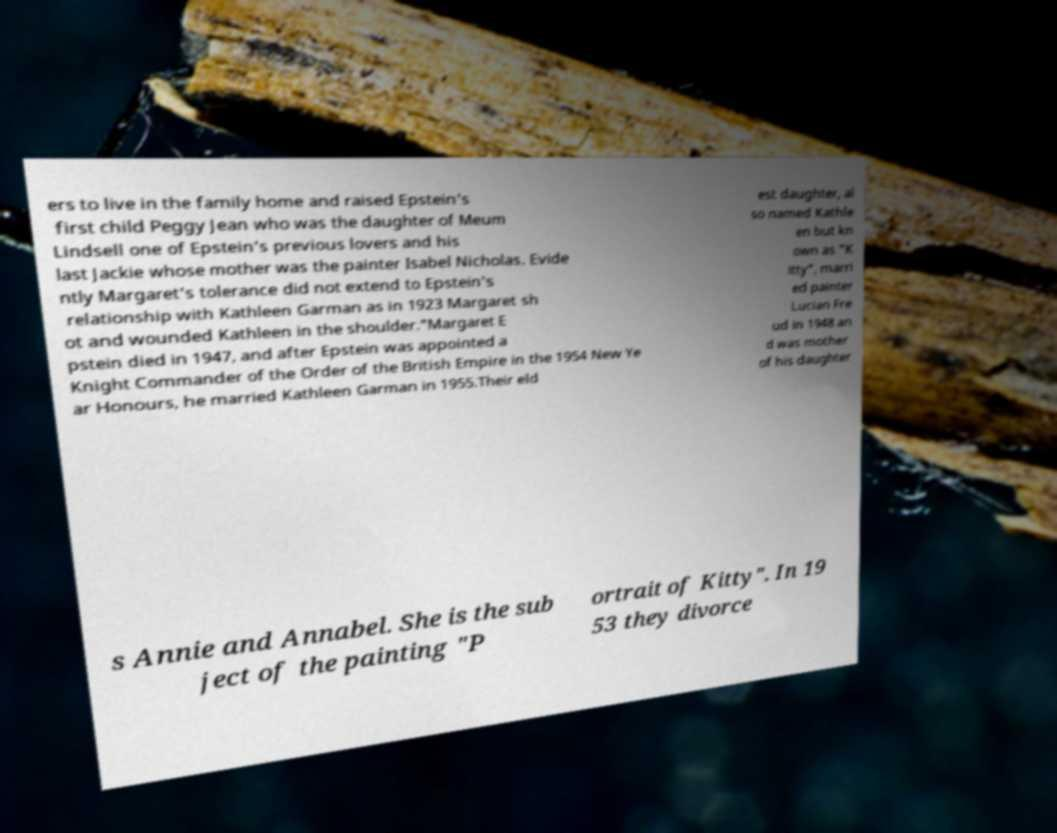Can you accurately transcribe the text from the provided image for me? ers to live in the family home and raised Epstein's first child Peggy Jean who was the daughter of Meum Lindsell one of Epstein's previous lovers and his last Jackie whose mother was the painter Isabel Nicholas. Evide ntly Margaret's tolerance did not extend to Epstein's relationship with Kathleen Garman as in 1923 Margaret sh ot and wounded Kathleen in the shoulder."Margaret E pstein died in 1947, and after Epstein was appointed a Knight Commander of the Order of the British Empire in the 1954 New Ye ar Honours, he married Kathleen Garman in 1955.Their eld est daughter, al so named Kathle en but kn own as "K itty", marri ed painter Lucian Fre ud in 1948 an d was mother of his daughter s Annie and Annabel. She is the sub ject of the painting "P ortrait of Kitty". In 19 53 they divorce 